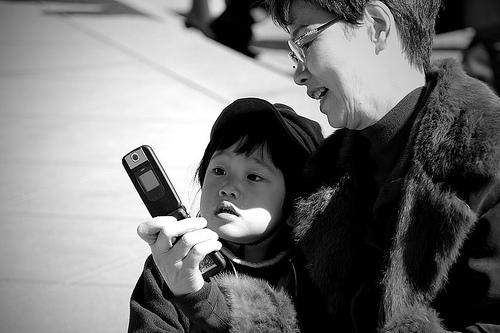What is she doing with the child? Please explain your reasoning. showing phone. The woman is holding her screen so the child can see it. 